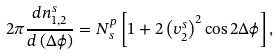Convert formula to latex. <formula><loc_0><loc_0><loc_500><loc_500>2 \pi \frac { d n ^ { s } _ { 1 , 2 } } { d \left ( \Delta \phi \right ) } = N ^ { p } _ { s } \left [ 1 + 2 \left ( v ^ { s } _ { 2 } \right ) ^ { 2 } \cos 2 \Delta \phi \right ] ,</formula> 